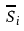<formula> <loc_0><loc_0><loc_500><loc_500>\overline { S } _ { i }</formula> 